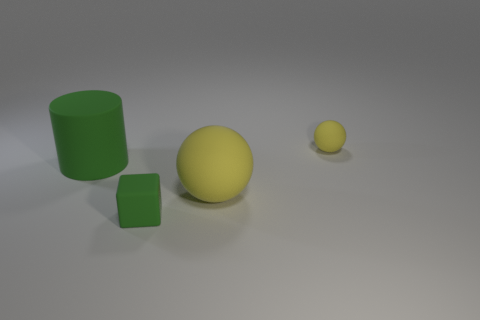Add 1 green rubber cylinders. How many objects exist? 5 Subtract all cylinders. How many objects are left? 3 Add 1 large green rubber things. How many large green rubber things are left? 2 Add 3 tiny matte blocks. How many tiny matte blocks exist? 4 Subtract 0 cyan cylinders. How many objects are left? 4 Subtract all green rubber objects. Subtract all big yellow rubber spheres. How many objects are left? 1 